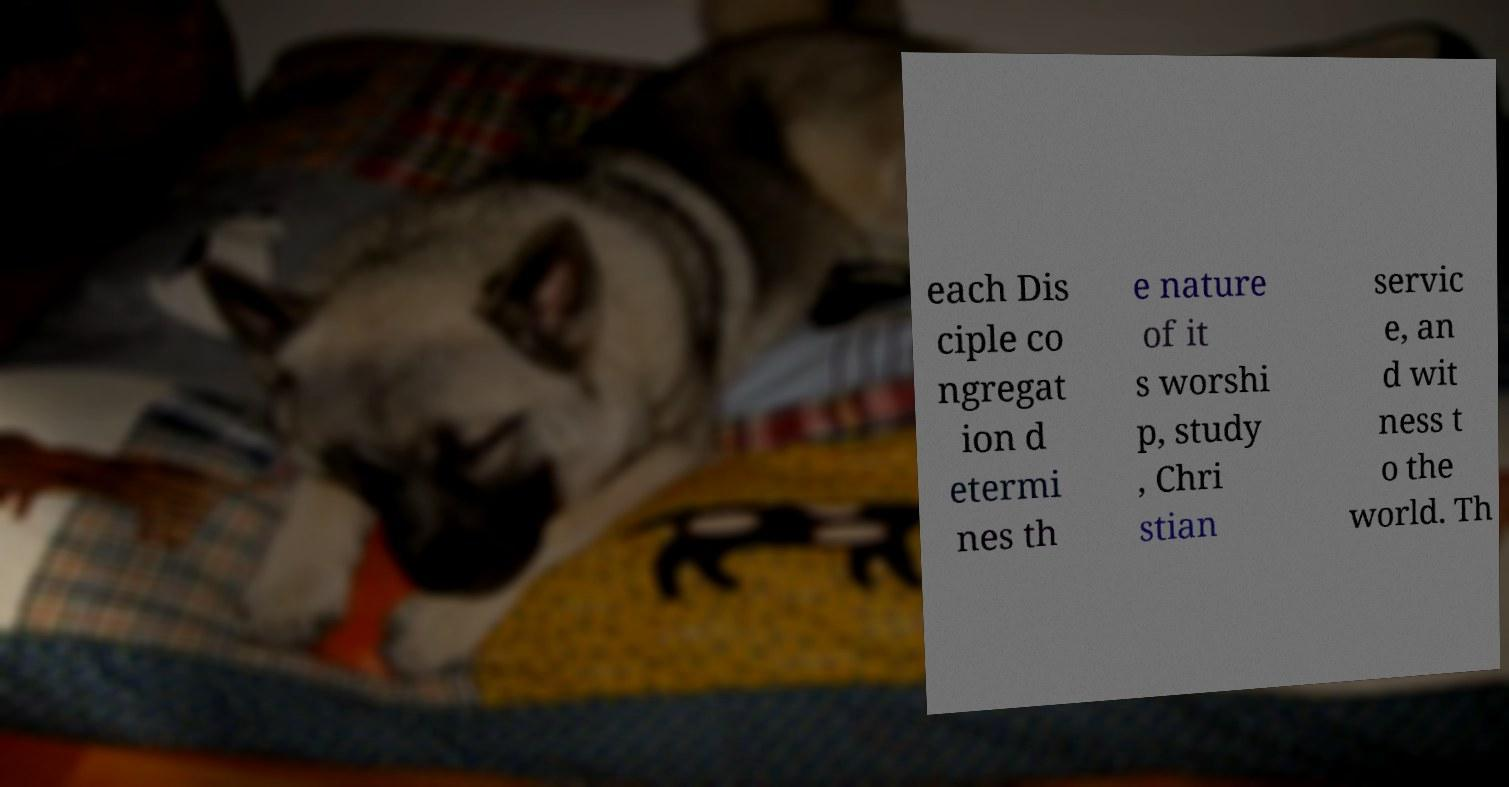I need the written content from this picture converted into text. Can you do that? each Dis ciple co ngregat ion d etermi nes th e nature of it s worshi p, study , Chri stian servic e, an d wit ness t o the world. Th 